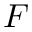Convert formula to latex. <formula><loc_0><loc_0><loc_500><loc_500>F</formula> 